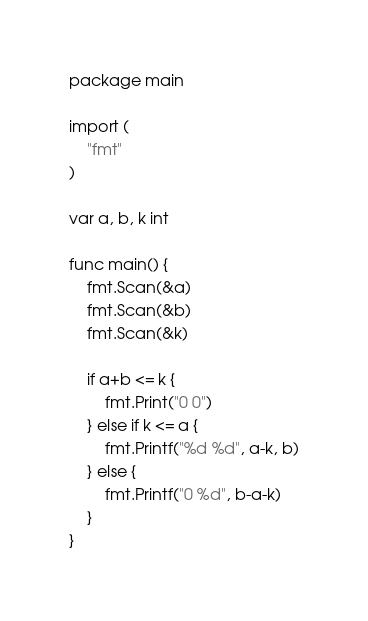Convert code to text. <code><loc_0><loc_0><loc_500><loc_500><_Go_>package main

import (
	"fmt"
)

var a, b, k int

func main() {
	fmt.Scan(&a)
	fmt.Scan(&b)
	fmt.Scan(&k)

	if a+b <= k {
		fmt.Print("0 0")
	} else if k <= a {
		fmt.Printf("%d %d", a-k, b)
	} else {
		fmt.Printf("0 %d", b-a-k)
	}
}
</code> 